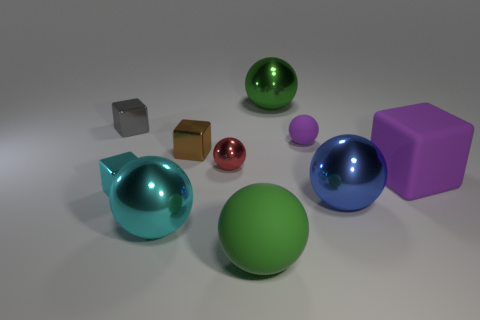What material is the gray thing that is the same shape as the small brown metallic thing?
Give a very brief answer. Metal. Are there any large gray objects that have the same material as the big blue object?
Give a very brief answer. No. Is the size of the brown thing the same as the green ball behind the big blue thing?
Provide a short and direct response. No. Are there any other matte blocks that have the same color as the big rubber cube?
Your response must be concise. No. Is the material of the small gray cube the same as the tiny red ball?
Provide a succinct answer. Yes. What number of shiny spheres are in front of the big blue metal sphere?
Make the answer very short. 1. The big thing that is in front of the small gray metallic cube and behind the blue ball is made of what material?
Provide a succinct answer. Rubber. How many other cubes are the same size as the cyan metallic block?
Offer a very short reply. 2. There is a sphere behind the tiny block behind the small matte object; what is its color?
Offer a very short reply. Green. Are there any blue metal things?
Your answer should be very brief. Yes. 